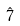<formula> <loc_0><loc_0><loc_500><loc_500>\hat { 7 }</formula> 